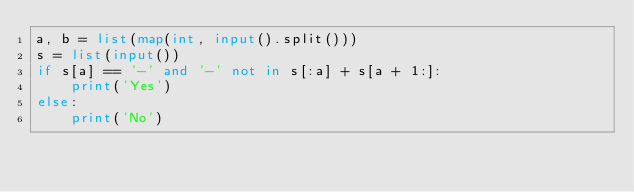Convert code to text. <code><loc_0><loc_0><loc_500><loc_500><_Python_>a, b = list(map(int, input().split()))
s = list(input())
if s[a] == '-' and '-' not in s[:a] + s[a + 1:]:
    print('Yes')
else:
    print('No')
</code> 